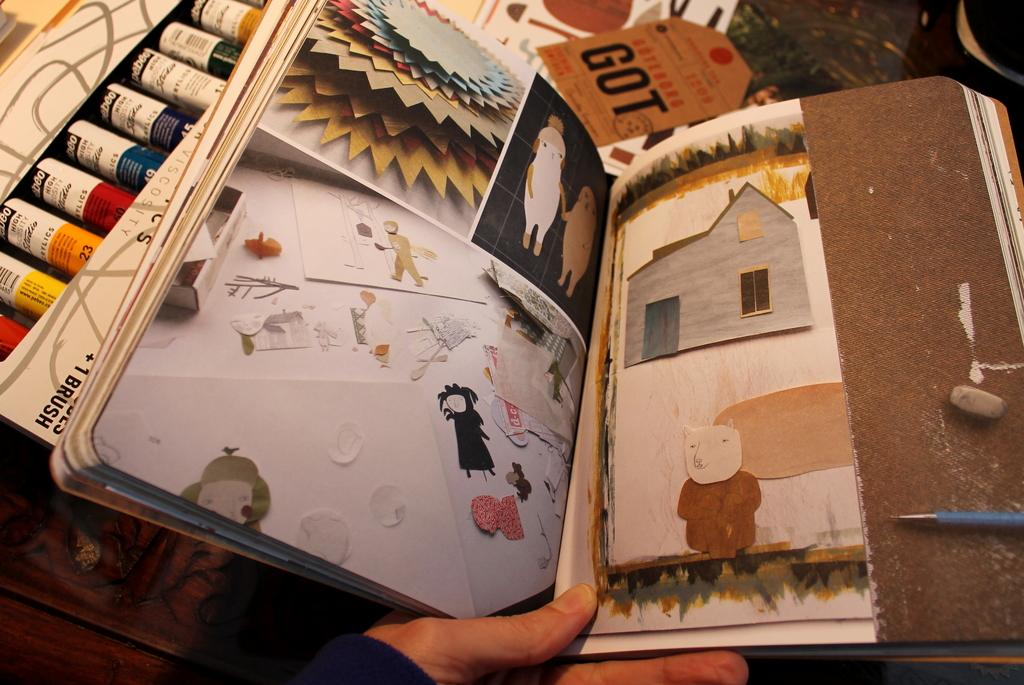Provide a one-sentence caption for the provided image. A scrapbook is decorated with a hodgepodge of images, including a tag with GOT on it. 